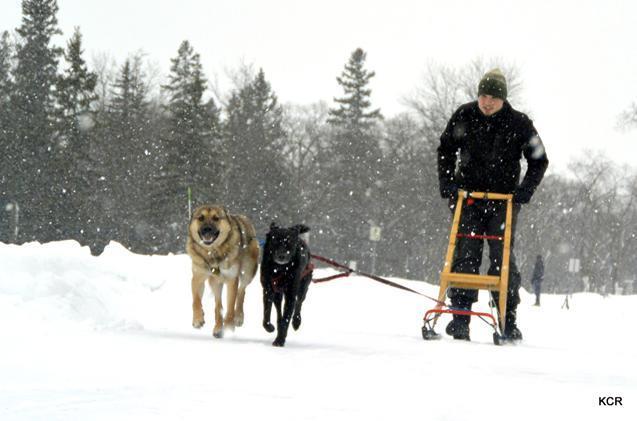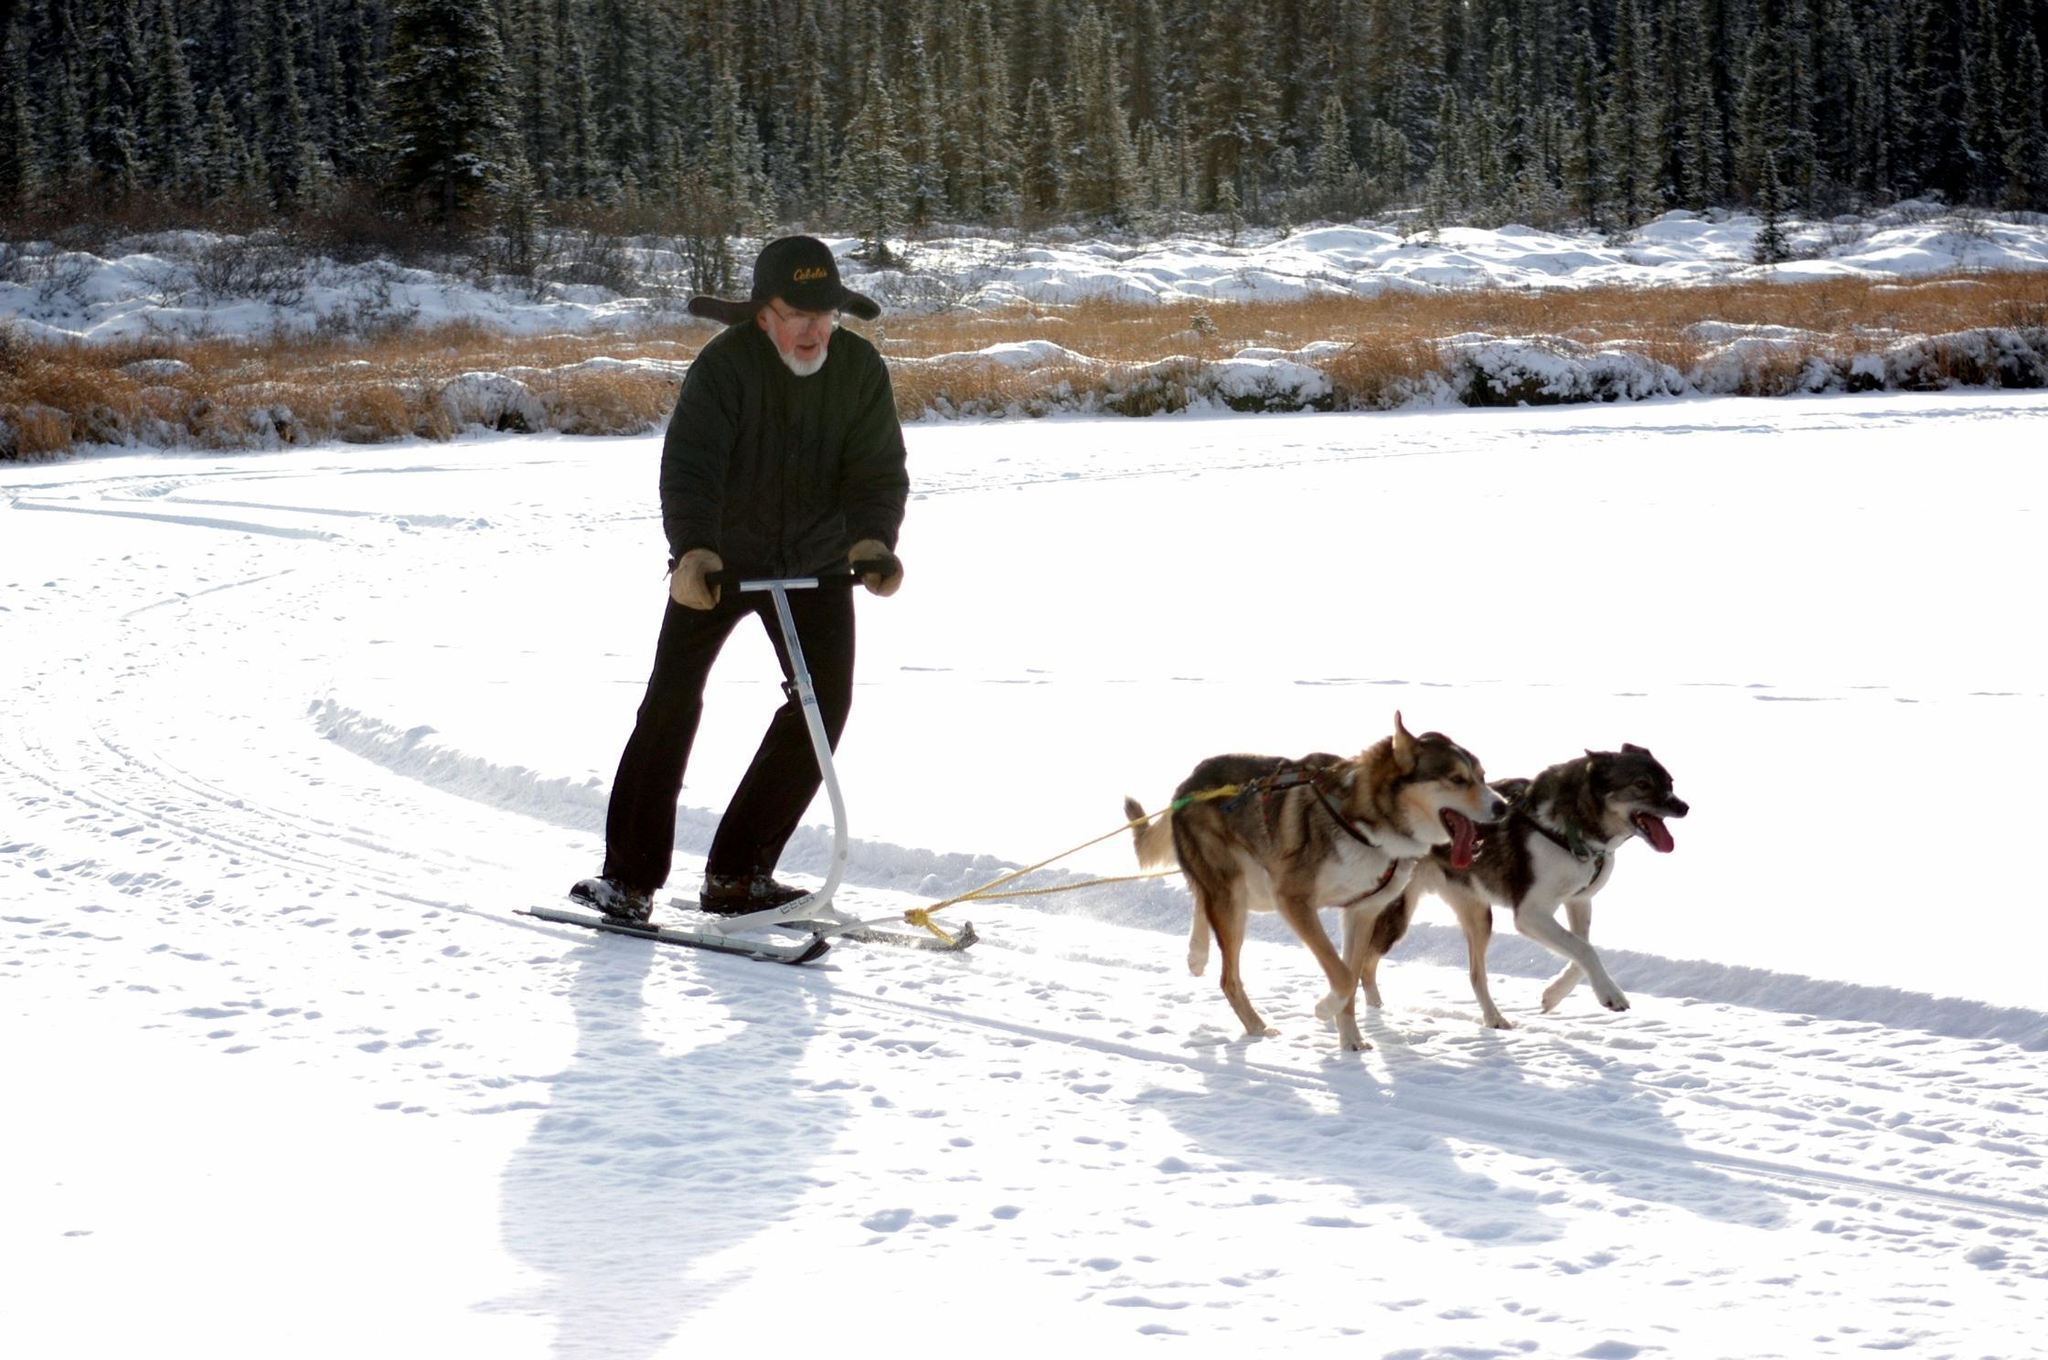The first image is the image on the left, the second image is the image on the right. Evaluate the accuracy of this statement regarding the images: "The right image shows one person standing behind a small sled pulled by no more than two dogs and heading rightward.". Is it true? Answer yes or no. Yes. The first image is the image on the left, the second image is the image on the right. Examine the images to the left and right. Is the description "There are more than four animals in harnesses." accurate? Answer yes or no. No. 